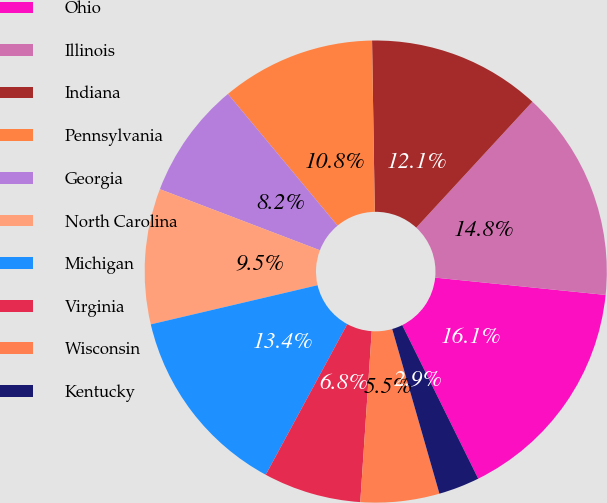<chart> <loc_0><loc_0><loc_500><loc_500><pie_chart><fcel>Ohio<fcel>Illinois<fcel>Indiana<fcel>Pennsylvania<fcel>Georgia<fcel>North Carolina<fcel>Michigan<fcel>Virginia<fcel>Wisconsin<fcel>Kentucky<nl><fcel>16.07%<fcel>14.75%<fcel>12.11%<fcel>10.79%<fcel>8.15%<fcel>9.47%<fcel>13.43%<fcel>6.83%<fcel>5.51%<fcel>2.87%<nl></chart> 